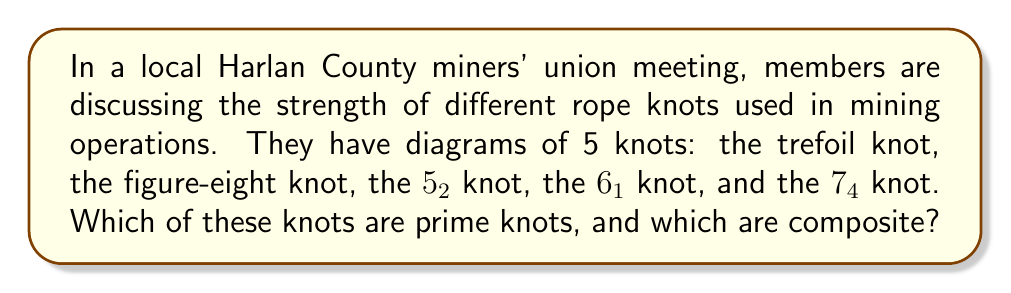What is the answer to this math problem? To determine whether a knot is prime or composite, we need to understand the concepts:

1. A prime knot is a non-trivial knot that cannot be decomposed into two simpler knots.
2. A composite knot is formed by connecting two or more prime knots.

Let's analyze each knot:

1. Trefoil knot:
   - The simplest non-trivial knot
   - Cannot be decomposed into simpler knots
   - Therefore, it's prime

2. Figure-eight knot:
   - The second simplest non-trivial knot
   - Cannot be decomposed into simpler knots
   - Therefore, it's prime

3. $5_2$ knot:
   - A knot with 5 crossings
   - Cannot be decomposed into simpler knots
   - Therefore, it's prime

4. $6_1$ knot:
   - A knot with 6 crossings
   - Cannot be decomposed into simpler knots
   - Therefore, it's prime

5. $7_4$ knot:
   - A knot with 7 crossings
   - Cannot be decomposed into simpler knots
   - Therefore, it's prime

All of these knots are prime knots, as they cannot be decomposed into simpler knots.
Answer: All 5 knots are prime knots. 